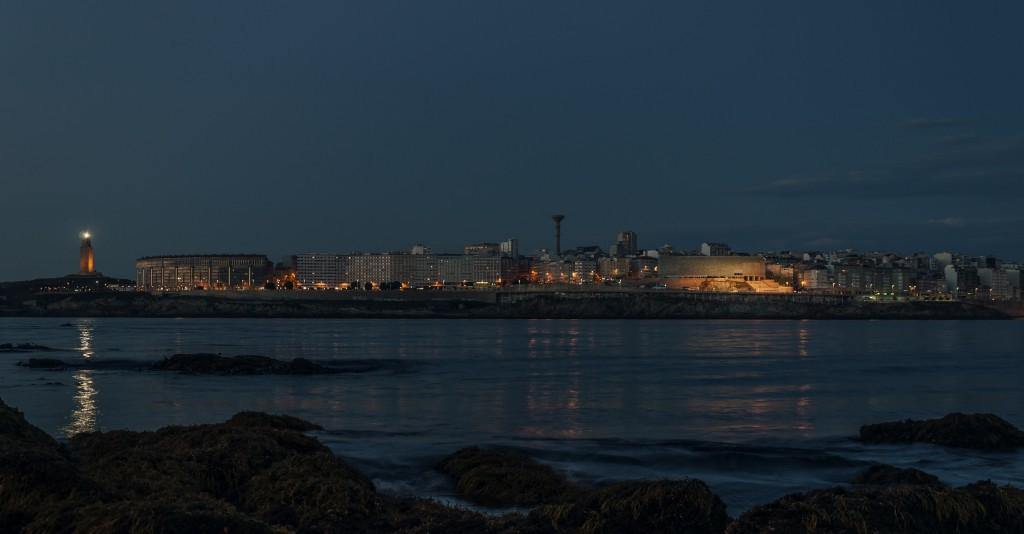What is the primary element visible in the image? There is water in the image. What can be seen in the background of the image? There are buildings, towers, lights, and a lighthouse in the background of the image. What is the condition of the sky in the image? The sky is visible at the top of the image. What is located at the bottom of the image? There are rocks at the bottom of the image. What type of guitar can be seen being played by the lighthouse keeper in the image? There is no guitar or lighthouse keeper present in the image. How many matches are visible in the image? There are no matches present in the image. 